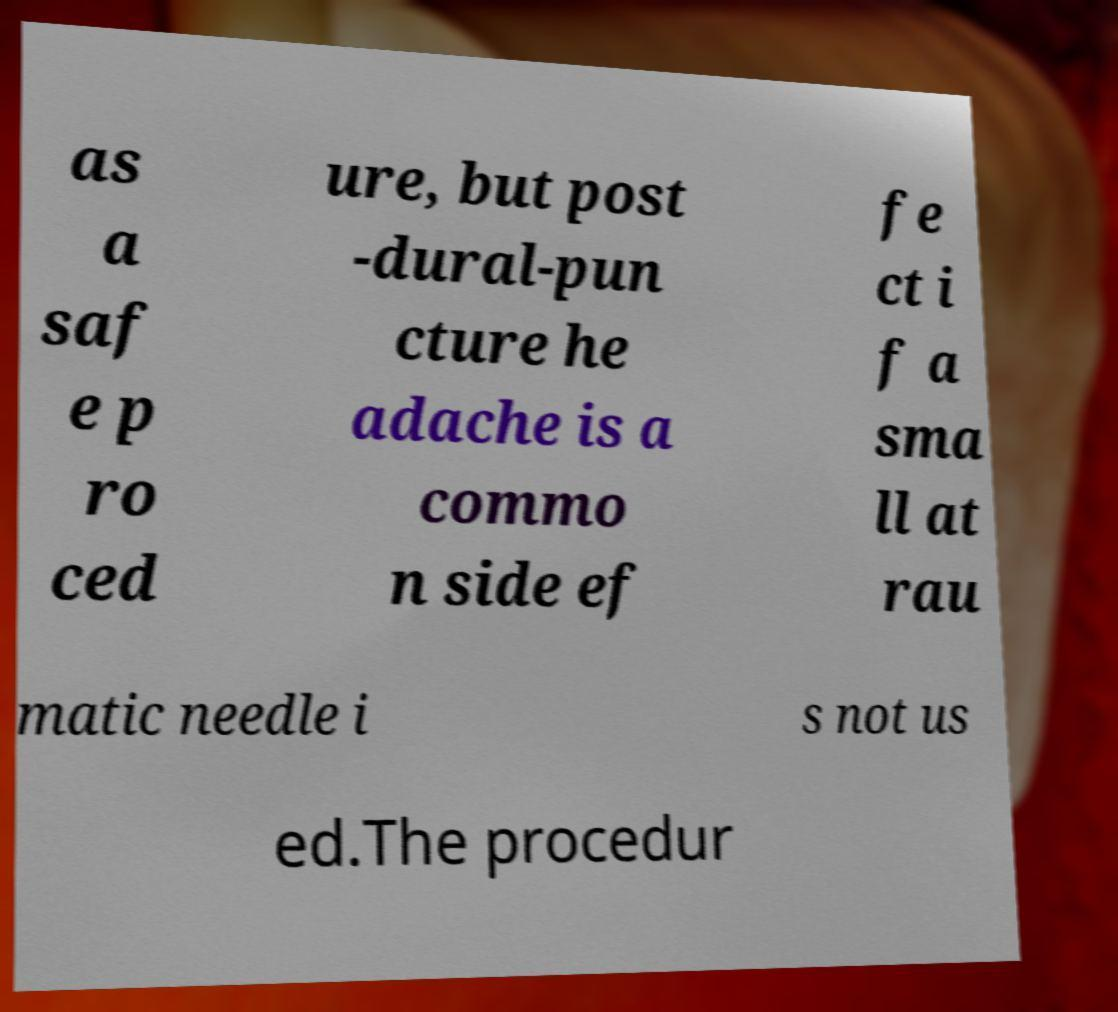Can you read and provide the text displayed in the image?This photo seems to have some interesting text. Can you extract and type it out for me? as a saf e p ro ced ure, but post -dural-pun cture he adache is a commo n side ef fe ct i f a sma ll at rau matic needle i s not us ed.The procedur 